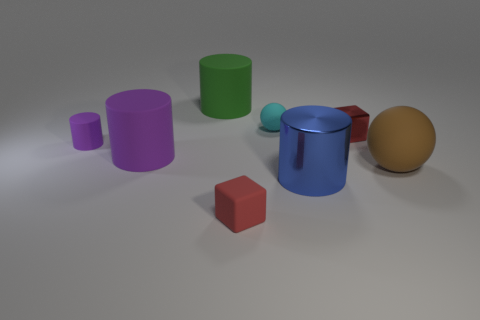Are there any other things that have the same shape as the large green matte thing?
Ensure brevity in your answer.  Yes. There is a big matte thing that is to the right of the tiny matte object that is in front of the big brown ball; what shape is it?
Your answer should be very brief. Sphere. There is a green object that is the same material as the brown ball; what shape is it?
Offer a terse response. Cylinder. There is a cylinder that is in front of the big rubber cylinder in front of the small cylinder; how big is it?
Your answer should be very brief. Large. There is a small purple matte object; what shape is it?
Provide a short and direct response. Cylinder. How many big things are red matte blocks or cyan matte objects?
Ensure brevity in your answer.  0. There is a metallic object that is the same shape as the red rubber object; what is its size?
Keep it short and to the point. Small. What number of tiny things are behind the blue metallic thing and on the left side of the metallic cube?
Give a very brief answer. 2. There is a big purple object; is its shape the same as the large rubber thing that is right of the green matte object?
Make the answer very short. No. Is the number of small cubes left of the cyan ball greater than the number of big yellow spheres?
Ensure brevity in your answer.  Yes. 